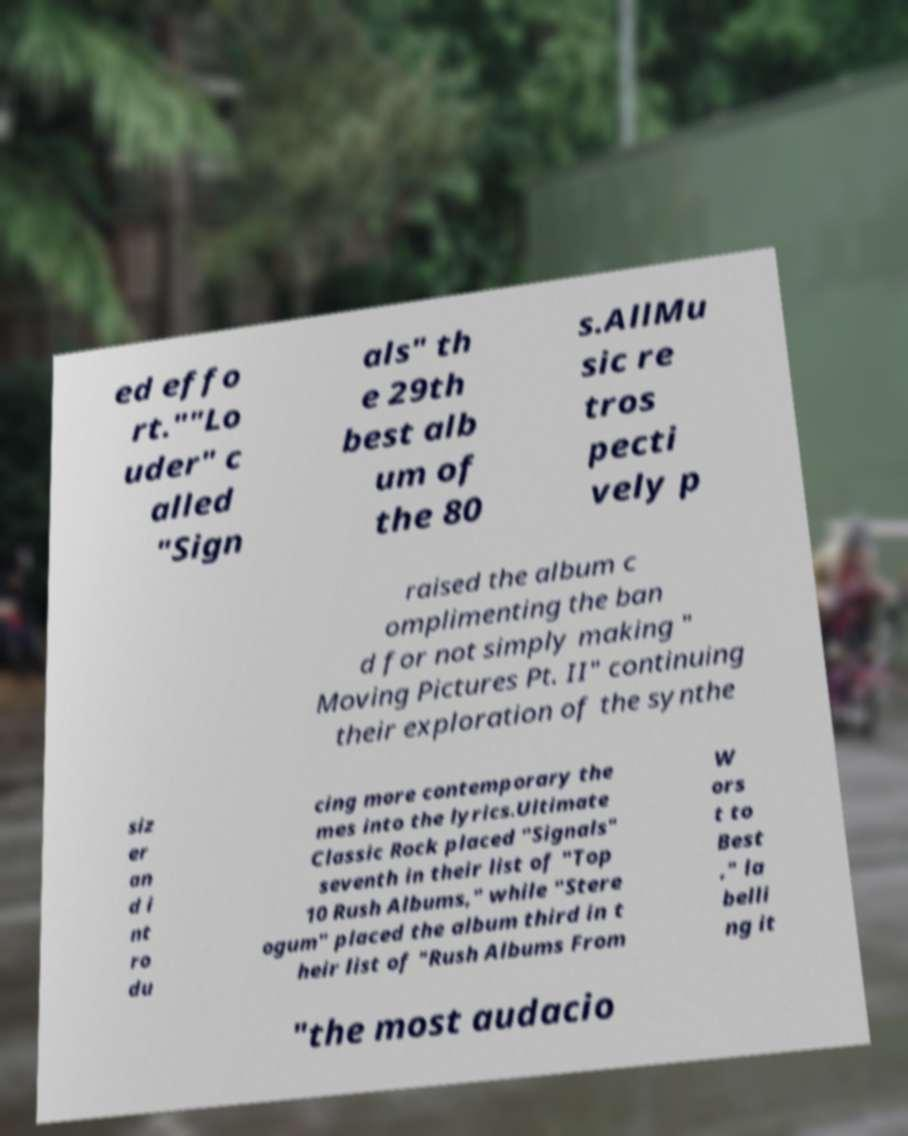Could you extract and type out the text from this image? ed effo rt.""Lo uder" c alled "Sign als" th e 29th best alb um of the 80 s.AllMu sic re tros pecti vely p raised the album c omplimenting the ban d for not simply making " Moving Pictures Pt. II" continuing their exploration of the synthe siz er an d i nt ro du cing more contemporary the mes into the lyrics.Ultimate Classic Rock placed "Signals" seventh in their list of "Top 10 Rush Albums," while "Stere ogum" placed the album third in t heir list of "Rush Albums From W ors t to Best ," la belli ng it "the most audacio 